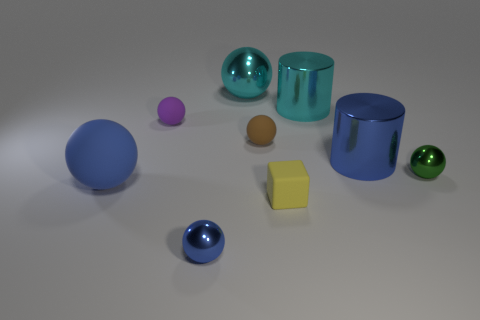Subtract all cyan metallic spheres. How many spheres are left? 5 Subtract all yellow cylinders. How many blue balls are left? 2 Subtract all cyan spheres. How many spheres are left? 5 Subtract 4 spheres. How many spheres are left? 2 Subtract all cylinders. How many objects are left? 7 Subtract 0 green cylinders. How many objects are left? 9 Subtract all cyan balls. Subtract all yellow cylinders. How many balls are left? 5 Subtract all yellow matte objects. Subtract all tiny rubber things. How many objects are left? 5 Add 4 blue rubber objects. How many blue rubber objects are left? 5 Add 2 rubber balls. How many rubber balls exist? 5 